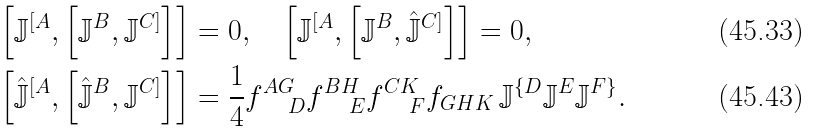Convert formula to latex. <formula><loc_0><loc_0><loc_500><loc_500>\left [ \mathbb { J } ^ { [ A } , \left [ \mathbb { J } ^ { B } , \mathbb { J } ^ { C ] } \right ] \right ] & = 0 , \quad \left [ \mathbb { J } ^ { [ A } , \left [ \mathbb { J } ^ { B } , \hat { \mathbb { J } } ^ { C ] } \right ] \right ] = 0 , \\ \left [ \hat { \mathbb { J } } ^ { [ A } , \left [ \hat { \mathbb { J } } ^ { B } , \mathbb { J } ^ { C ] } \right ] \right ] & = \frac { 1 } { 4 } f _ { \quad D } ^ { A G } f _ { \quad E } ^ { B H } f _ { \quad F } ^ { C K } f _ { G H K } \, \mathbb { J } ^ { \{ D } \mathbb { J } ^ { E } \mathbb { J } ^ { F \} } .</formula> 